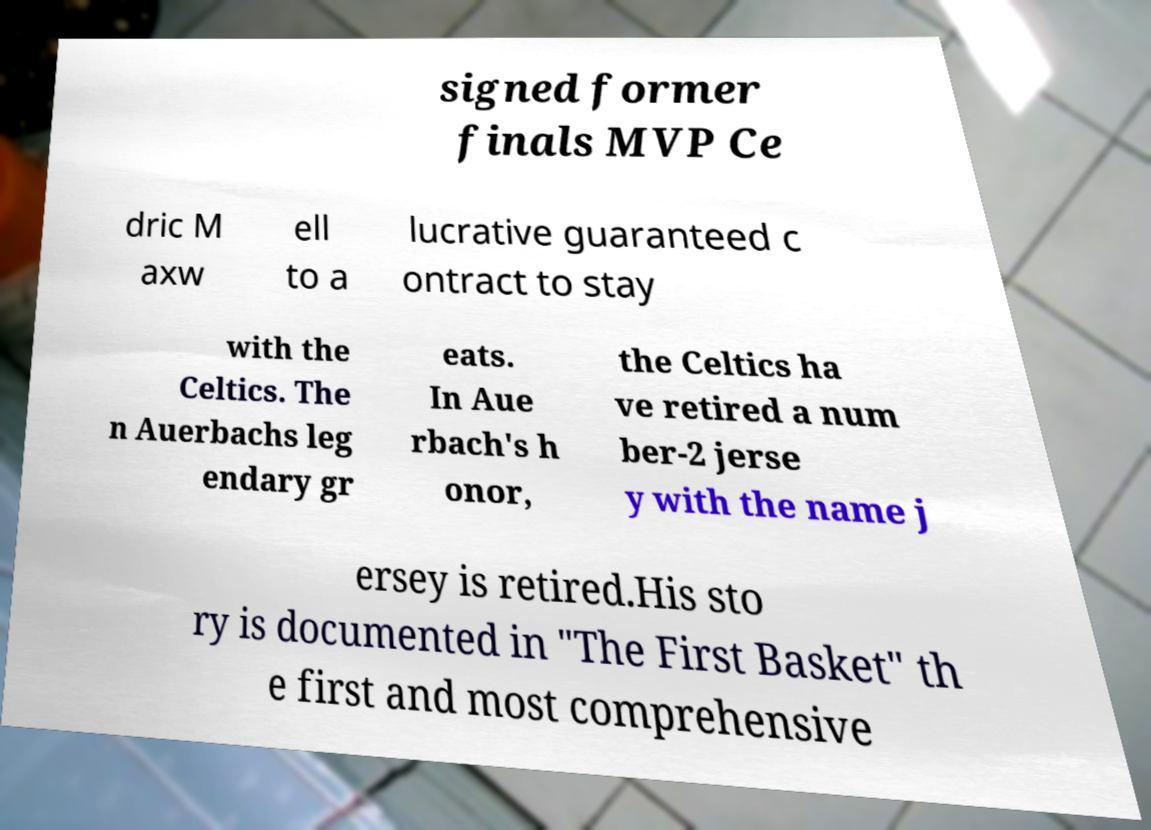Can you accurately transcribe the text from the provided image for me? signed former finals MVP Ce dric M axw ell to a lucrative guaranteed c ontract to stay with the Celtics. The n Auerbachs leg endary gr eats. In Aue rbach's h onor, the Celtics ha ve retired a num ber-2 jerse y with the name j ersey is retired.His sto ry is documented in "The First Basket" th e first and most comprehensive 